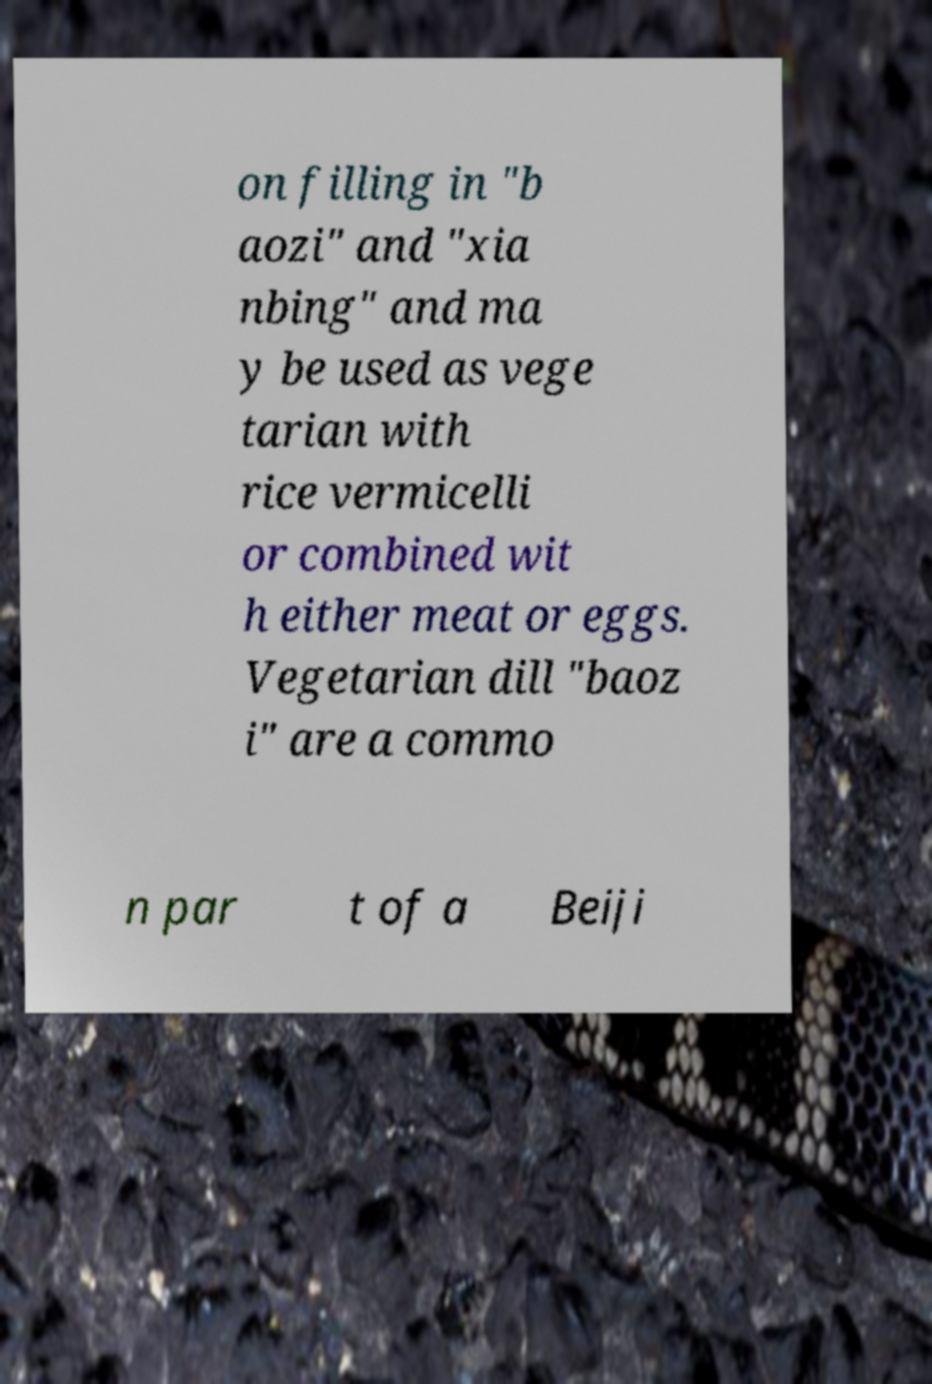Can you accurately transcribe the text from the provided image for me? on filling in "b aozi" and "xia nbing" and ma y be used as vege tarian with rice vermicelli or combined wit h either meat or eggs. Vegetarian dill "baoz i" are a commo n par t of a Beiji 